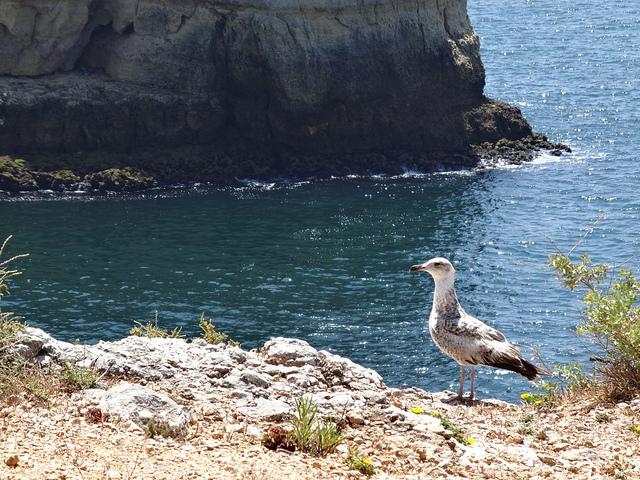Is this a beach?
Give a very brief answer. No. Does this animal fly?
Keep it brief. Yes. What type of animal is this?
Keep it brief. Bird. 